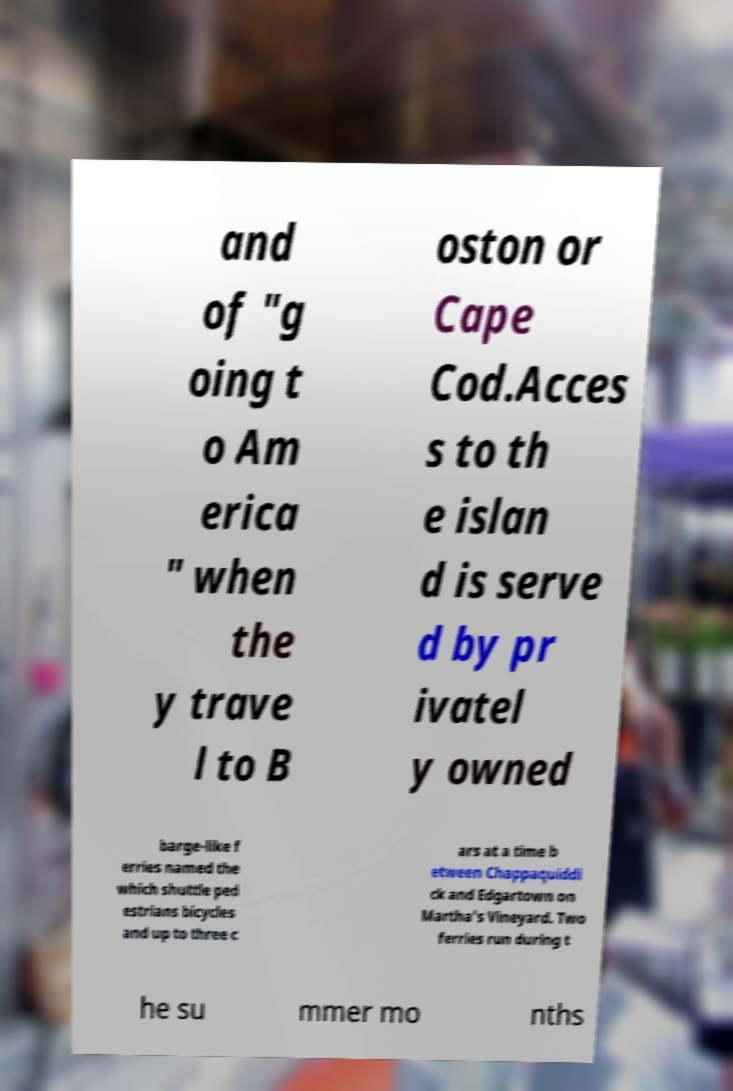Can you read and provide the text displayed in the image?This photo seems to have some interesting text. Can you extract and type it out for me? and of "g oing t o Am erica " when the y trave l to B oston or Cape Cod.Acces s to th e islan d is serve d by pr ivatel y owned barge-like f erries named the which shuttle ped estrians bicycles and up to three c ars at a time b etween Chappaquiddi ck and Edgartown on Martha's Vineyard. Two ferries run during t he su mmer mo nths 